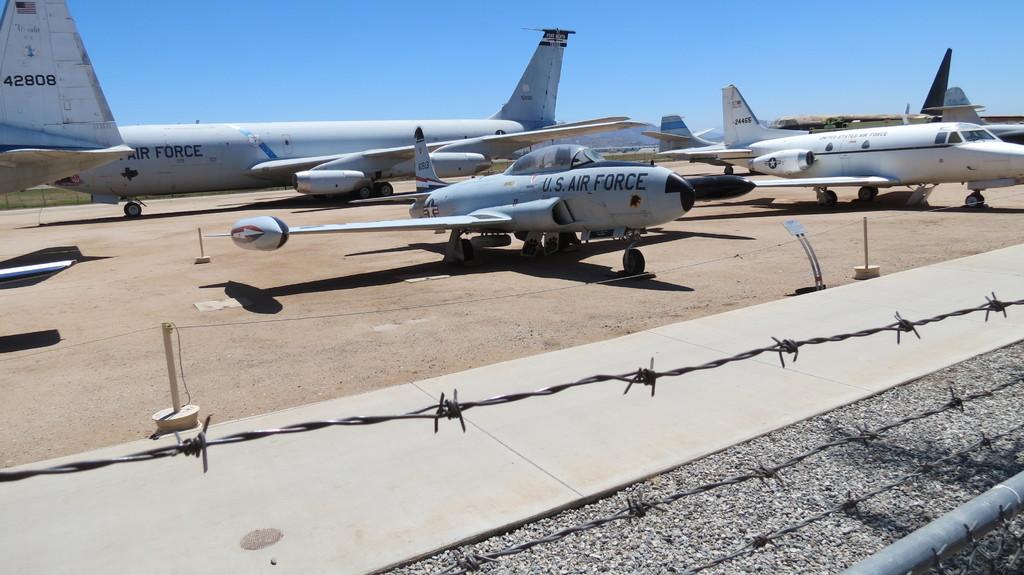What military branch does the plane belong to?
Ensure brevity in your answer.  Air force. Are those airforce planes?
Keep it short and to the point. Yes. 